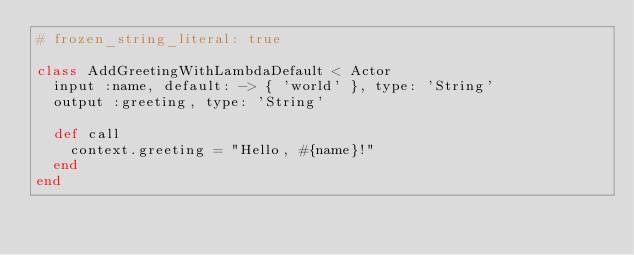<code> <loc_0><loc_0><loc_500><loc_500><_Ruby_># frozen_string_literal: true

class AddGreetingWithLambdaDefault < Actor
  input :name, default: -> { 'world' }, type: 'String'
  output :greeting, type: 'String'

  def call
    context.greeting = "Hello, #{name}!"
  end
end
</code> 